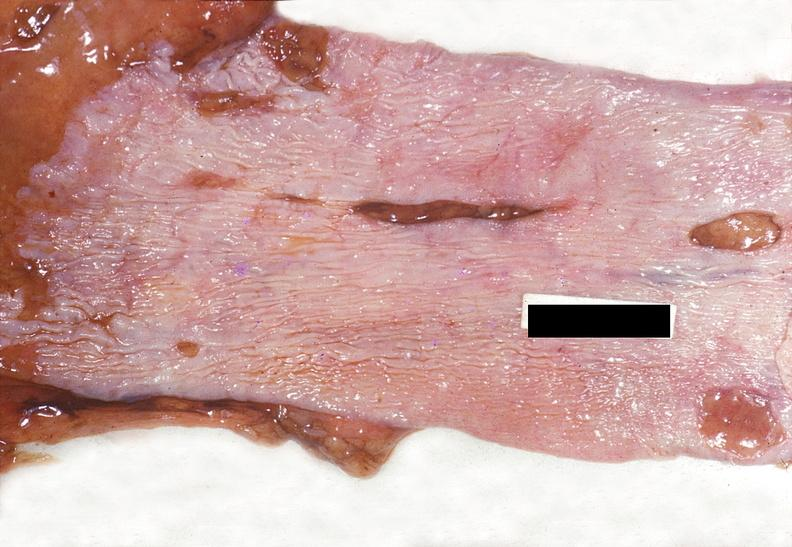where does this belong to?
Answer the question using a single word or phrase. Gastrointestinal system 